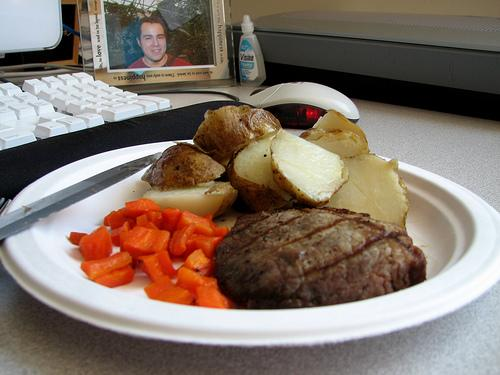Where is this kind of plate normally used? Please explain your reasoning. picnic. Because its a disposable plate. 